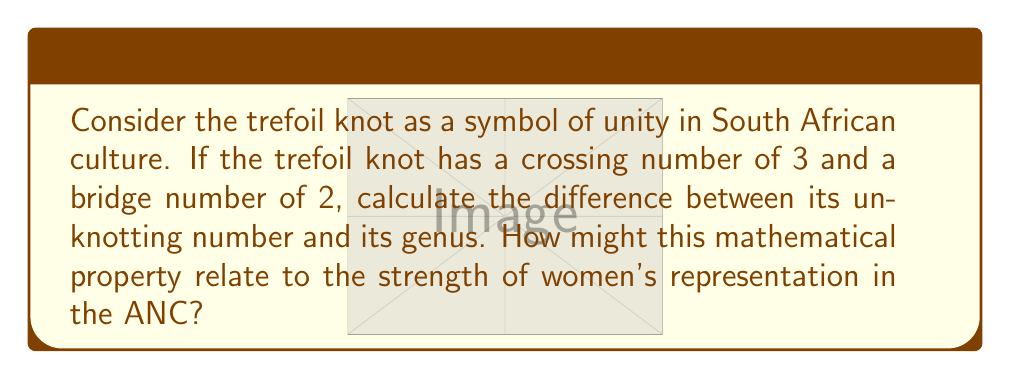Teach me how to tackle this problem. Let's approach this step-by-step:

1) The trefoil knot is the simplest non-trivial knot. Its properties are:
   - Crossing number: 3
   - Bridge number: 2
   - Unknotting number: 1
   - Genus: 1

2) To calculate the difference between the unknotting number and genus:
   $$\text{Difference} = \text{Unknotting number} - \text{Genus}$$
   $$\text{Difference} = 1 - 1 = 0$$

3) The zero difference between the unknotting number and genus indicates a perfect balance. This can be interpreted as representing equality and balance in leadership.

4) In the context of women's representation in the ANC:
   - The trefoil knot's three crossings could symbolize the three branches of government.
   - The bridge number of 2 could represent the bridging of gender gaps.
   - The balance between unknotting number and genus (difference of 0) could symbolize the ideal of equal representation of women in the ANC and government.

5) This mathematical property of the trefoil knot, where unknotting number equals genus, is unique among prime knots. This uniqueness could be seen as reflecting the ANC's commitment to women's empowerment, setting it apart in South African politics.
Answer: 0 